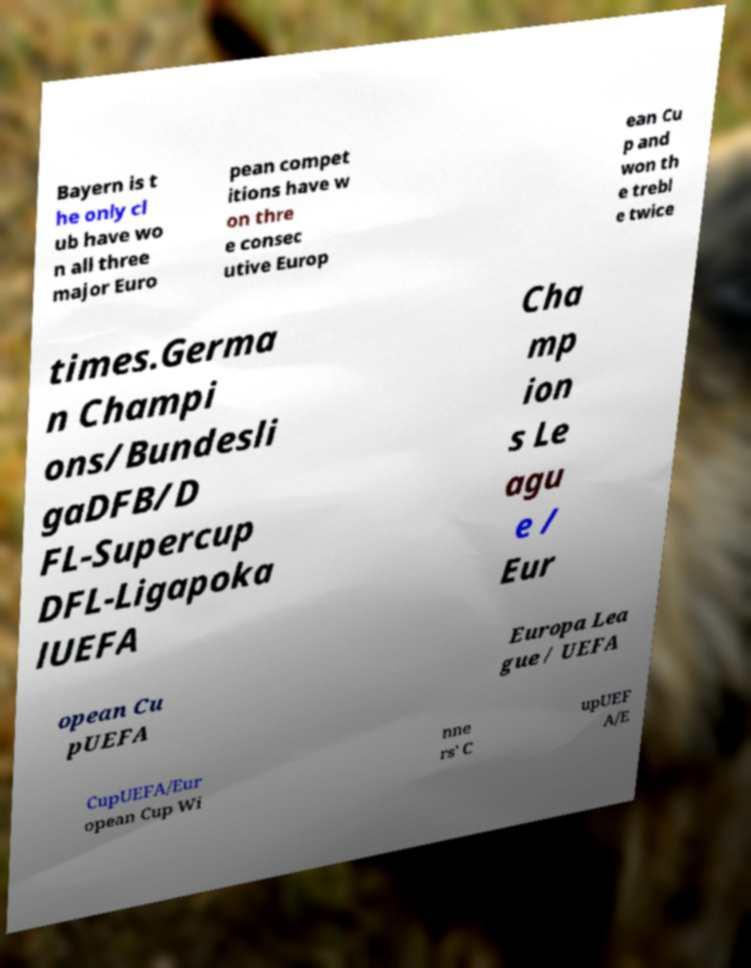Could you assist in decoding the text presented in this image and type it out clearly? Bayern is t he only cl ub have wo n all three major Euro pean compet itions have w on thre e consec utive Europ ean Cu p and won th e trebl e twice times.Germa n Champi ons/Bundesli gaDFB/D FL-Supercup DFL-Ligapoka lUEFA Cha mp ion s Le agu e / Eur opean Cu pUEFA Europa Lea gue / UEFA CupUEFA/Eur opean Cup Wi nne rs' C upUEF A/E 